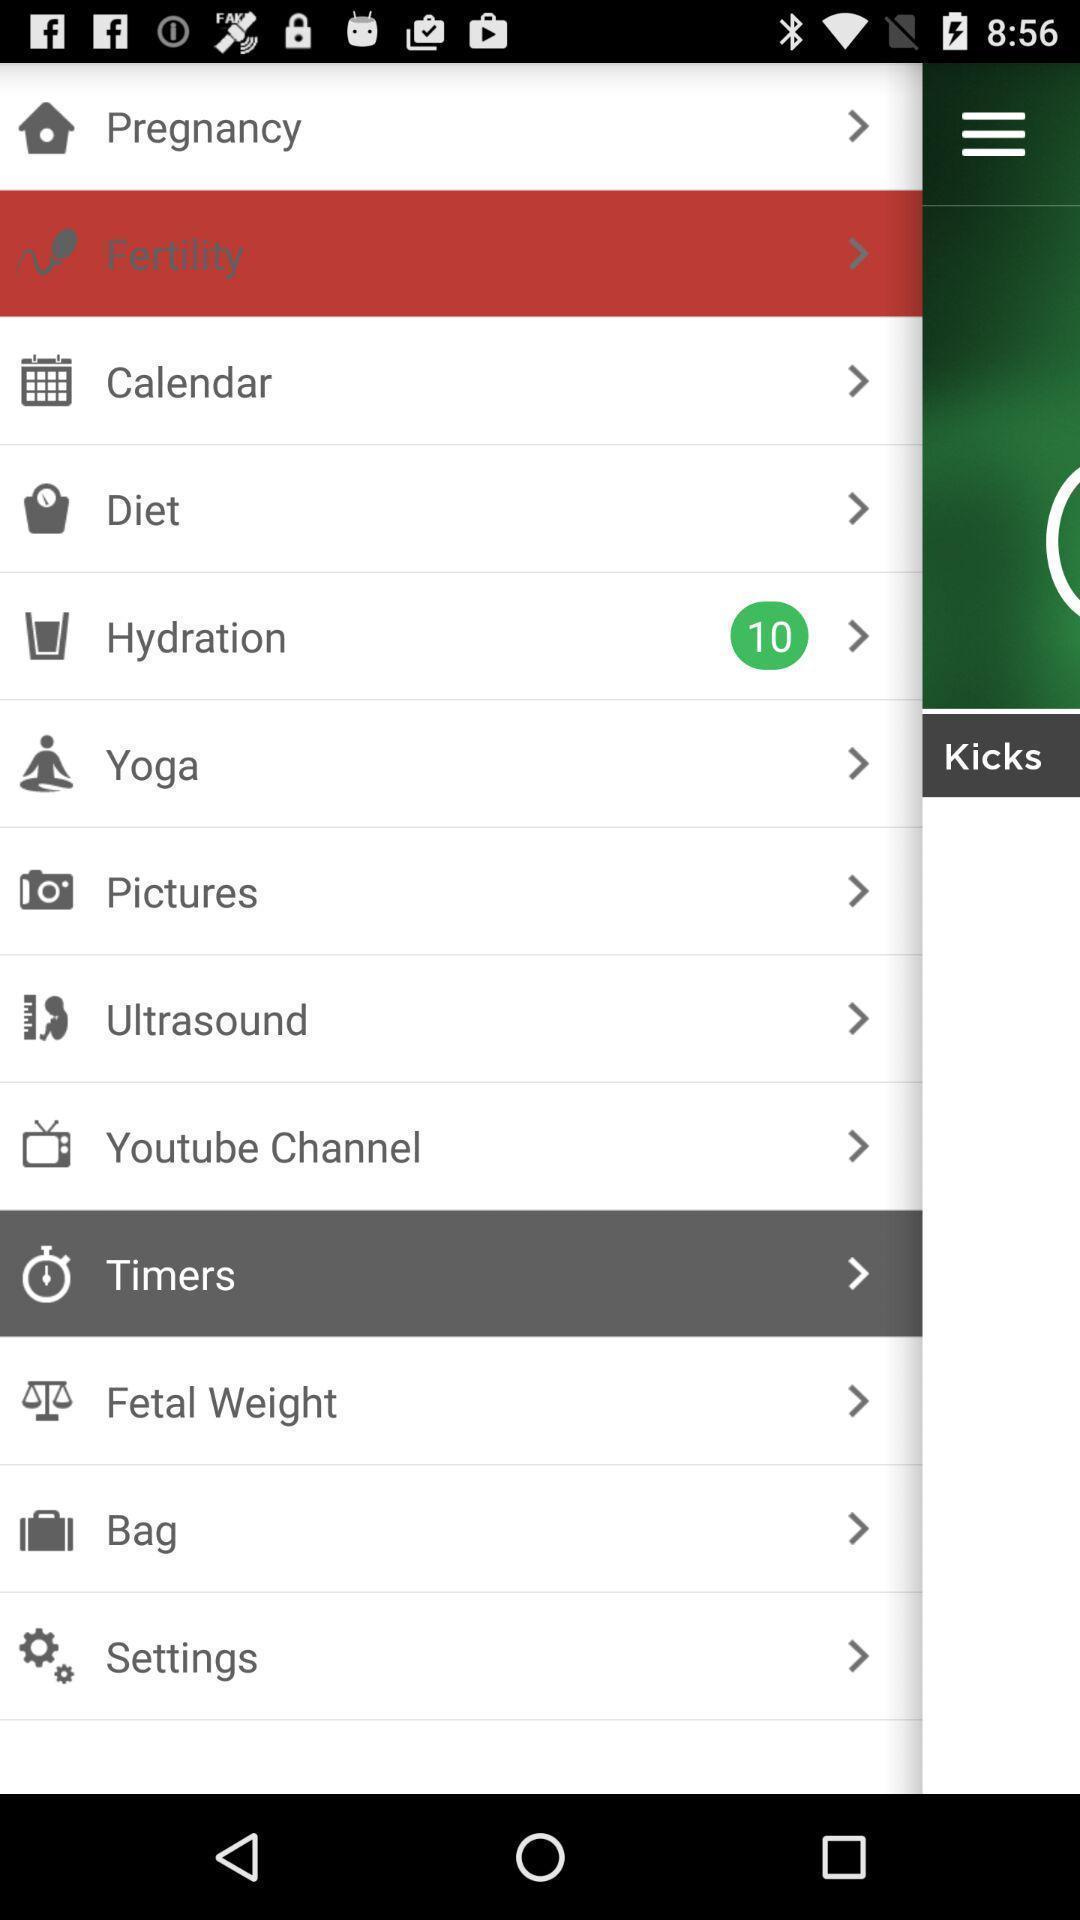Summarize the information in this screenshot. Pop-up showing menu in medial and health app. 